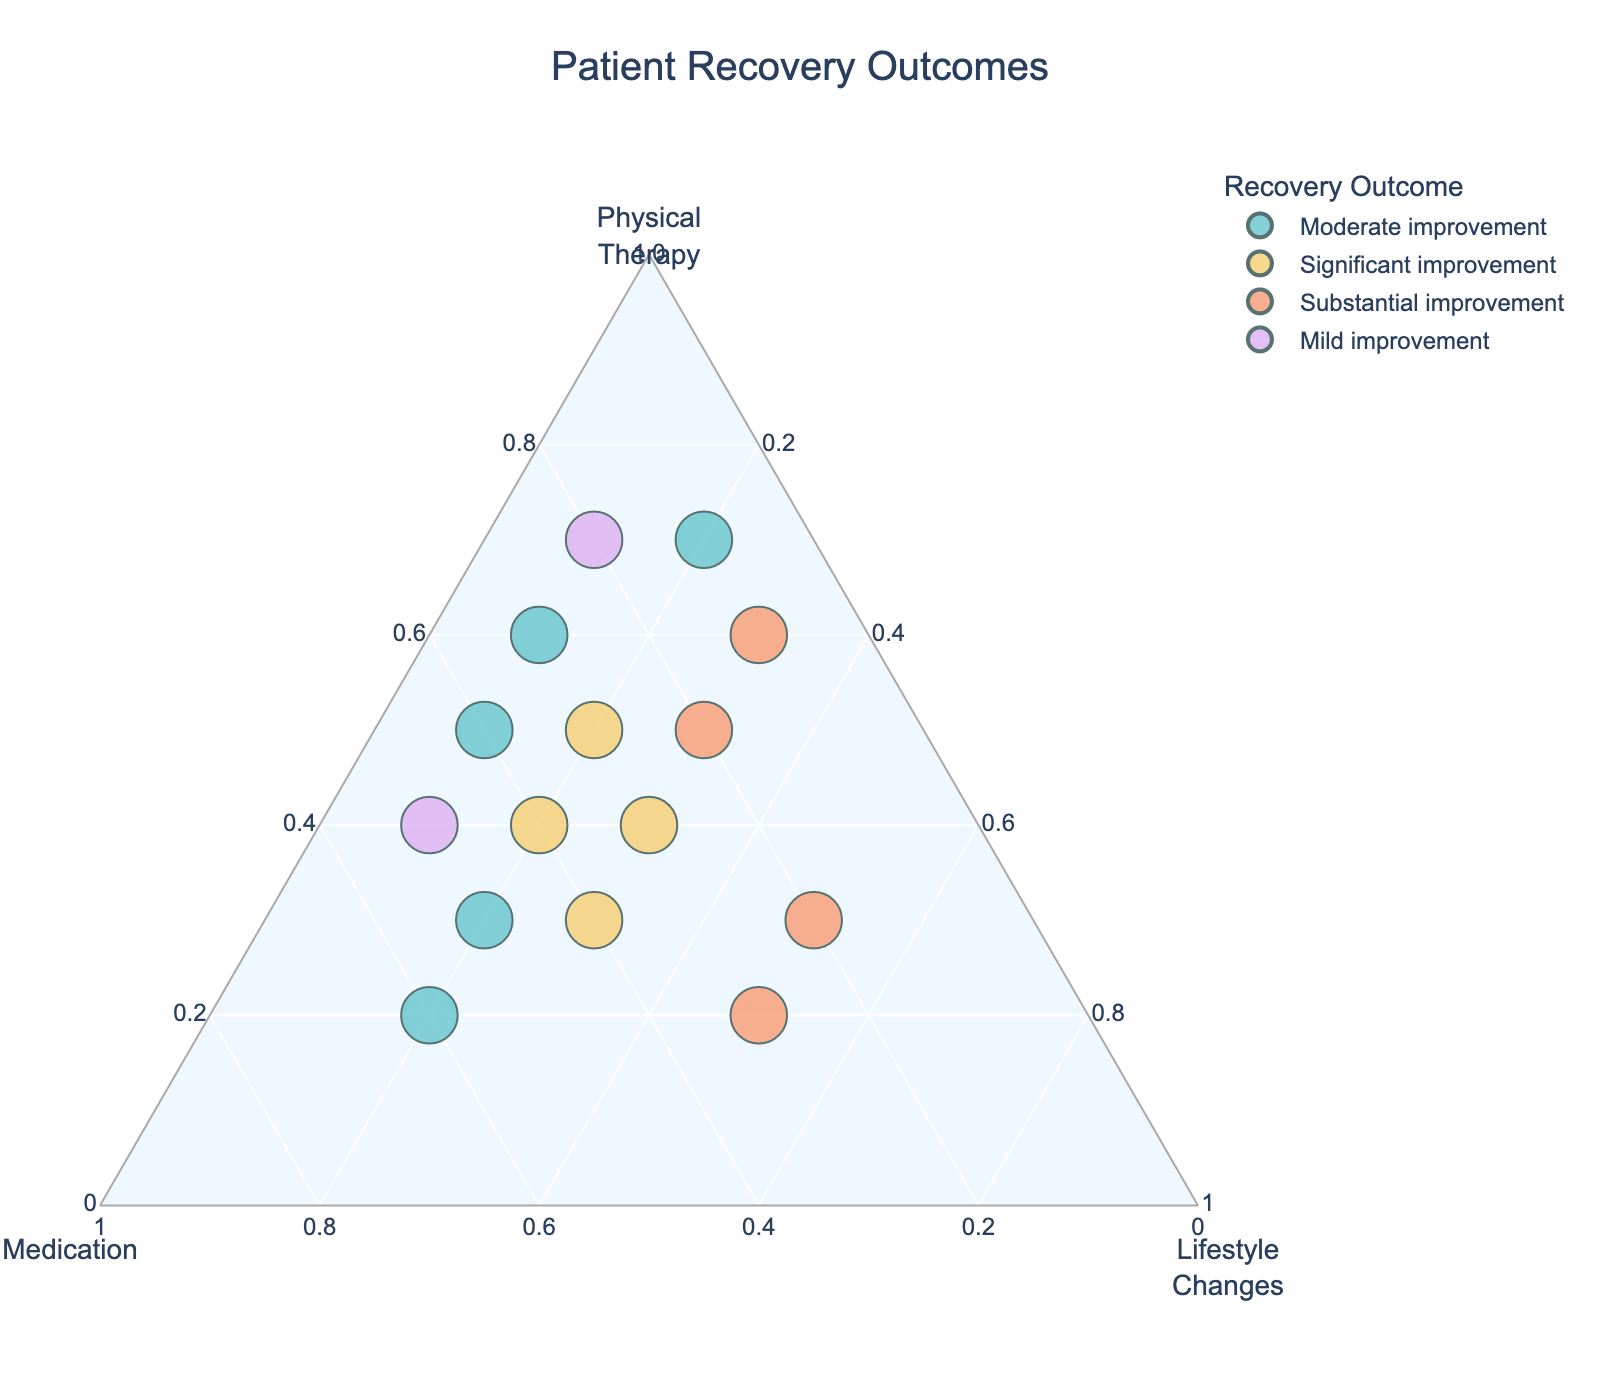What is the title of the ternary plot? The title is usually found at the top of the plot. In this case, the title provided in the code is "Patient Recovery Outcomes".
Answer: Patient Recovery Outcomes What are the three variables represented on the axes of the plot? In a ternary plot, each axis represents one of the three components. Here, the axes represent "Physical Therapy," "Medication," and "Lifestyle Changes" based on the labels.
Answer: Physical Therapy, Medication, Lifestyle Changes How many data points are represented in the plot? To determine the number of data points, you need to count the entries in the dataset. There are 14 rows of data, hence there are 14 points represented in the plot.
Answer: 14 Which recovery outcome appears the most in the plot? By visually examining the plot, you can count the occurrences of each recovery outcome. In the dataset, "Moderate improvement" appears 4 times, which is the highest frequency.
Answer: Moderate improvement How many data points indicate a "Substantial improvement"? By checking the legend and counting the corresponding points on the plot, you find that there are 3 points indicating a "Substantial improvement".
Answer: 3 Which coordinate has the highest proportion of "Physical Therapy"? By looking at the positioning of the points on the ternary plot, the data point closest to the "Physical Therapy" vertex with coordinates (0.7, 0.2, 0.1) indicates "Mild improvement".
Answer: Mild improvement Is there a data point with equal proportions of "Physical Therapy" and "Medication"? In the dataset, the point with equal proportions for "Physical Therapy" and "Medication" is (0.4, 0.4, 0.2), indicating "Significant improvement".
Answer: Yes What is the average proportion of "Physical Therapy" for outcomes labeled as "Moderate improvement"? Add the proportions of "Physical Therapy" for the points with "Moderate improvement" and divide by the number of such points: (0.6 + 0.3 + 0.5 + 0.7) / 4 = 2.1 / 4 = 0.525.
Answer: 0.525 Which outcome has the highest spread in terms of distribution on the plot? To determine the spread, you can assess how far apart the points related to each outcome are located. "Moderate improvement" points are spread out across different sections, indicating a larger spread.
Answer: Moderate improvement Which data point is closest to the center of the ternary plot? The center of the ternary plot corresponds to equal proportions of the three variables. The point (0.4, 0.3, 0.3) indicating "Significant improvement" is closest to the center.
Answer: Significant improvement 